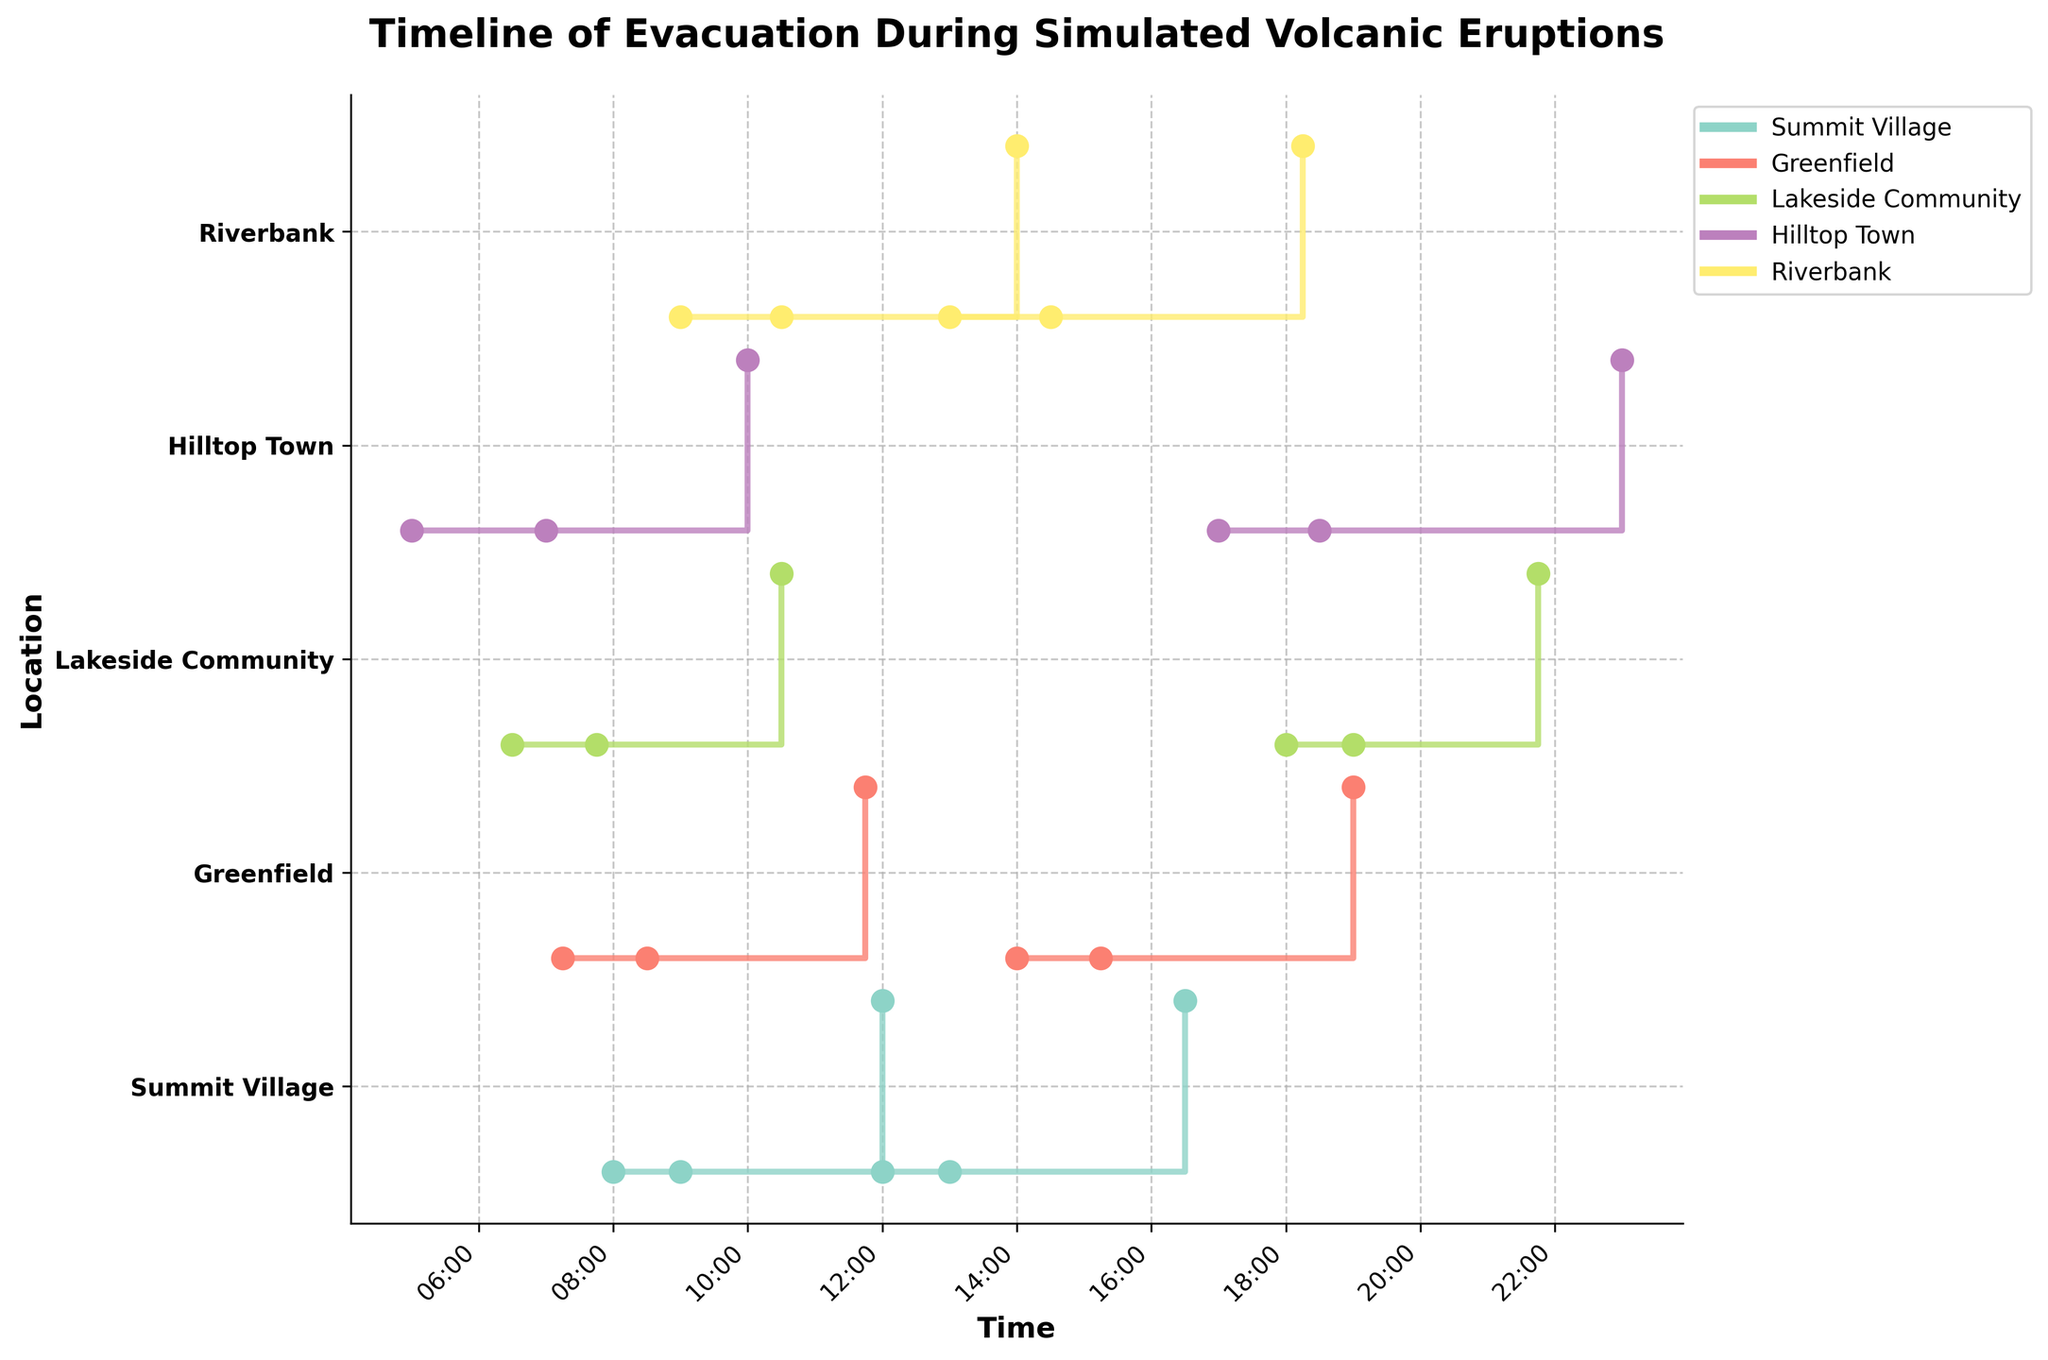What is the title of the figure? The title of the figure is usually displayed at the top and summarizes the content of the visualization. In this case, it states the main topic of the timeline of evacuation times during simulated volcanic eruptions.
Answer: Timeline of Evacuation During Simulated Volcanic Eruptions How many unique locations are represented in the plot? By looking at the y-axis ticks on the figure, we can count the number of unique locations listed. These represent the different areas affected by the simulated volcanic eruptions.
Answer: 5 Which location has the shortest evacuation time in the morning simulation? To find this, look at the stair steps that start in the morning (early times on the x-axis) and check the differences between their evacuation start and end times. Inspect the step lengths visually corresponding to each location.
Answer: Lakeside Community What is the range of times represented on the x-axis? The x-axis shows the span of time over which events and evacuations occurred. This can be identified by looking at the earliest and latest times marked on the x-axis.
Answer: 05:00 to 23:00 Which location has the longest evacuation duration in the evening simulation? Identify the stair steps starting in the evening (later times on the x-axis) and then compare the lengths of the steps that indicate evacuation times for the different locations.
Answer: Hilltop Town What color represents Summit Village in the plot? Each location is represented by a different color. Identifying the specific color used for Summit Village can be done by looking at the legend beside the plot.
Answer: The distinct color associated with Summit Village from the legend How many evacuation events are recorded for each location? This can be determined by counting the number of stair steps or segments corresponding to each unique location on the y-axis. This represents the number of evacuation events plotted on the figure.
Answer: 2 for each location Which location had an evacuation that started the earliest in the morning? Look at the starting times of all evacuation events and identify the earliest time on the x-axis linked to a specific location on the y-axis.
Answer: Hilltop Town at 05:00 What is the total evacuation time for Summit Village? Add up the individual evacuation times listed for Summit Village. Combine the duration of each event to find the total time for the location. 1. See the stair steps for Summit Village. 2. Note each evacuation duration (3 hours and 3.5 hours). 3. Sum the durations (3 + 3.5).
Answer: 6.5 hours Compare the morning evacuation duration between Greenfield and Riverbank. Which one took longer? For morning evacuations in the specific locations, derive the duration from the start and end times on the plot. Assess which duration is longer visually or through calculation.
Answer: Riverbank 